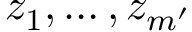Convert formula to latex. <formula><loc_0><loc_0><loc_500><loc_500>z _ { 1 } , \dots , z _ { m ^ { \prime } }</formula> 